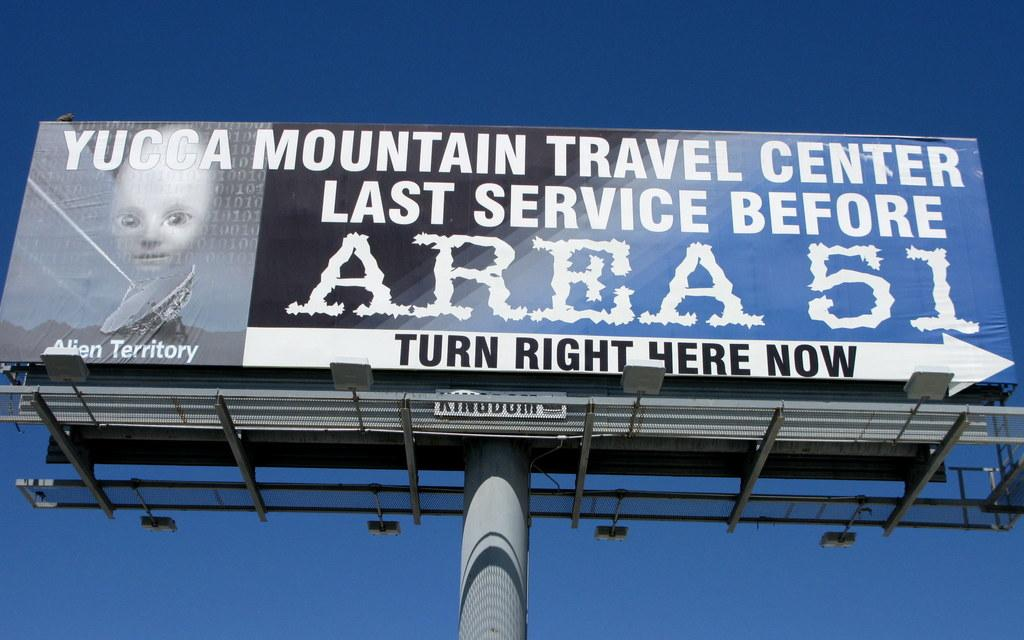<image>
Present a compact description of the photo's key features. A billboard points to the last service area before arriving at Area 51. 